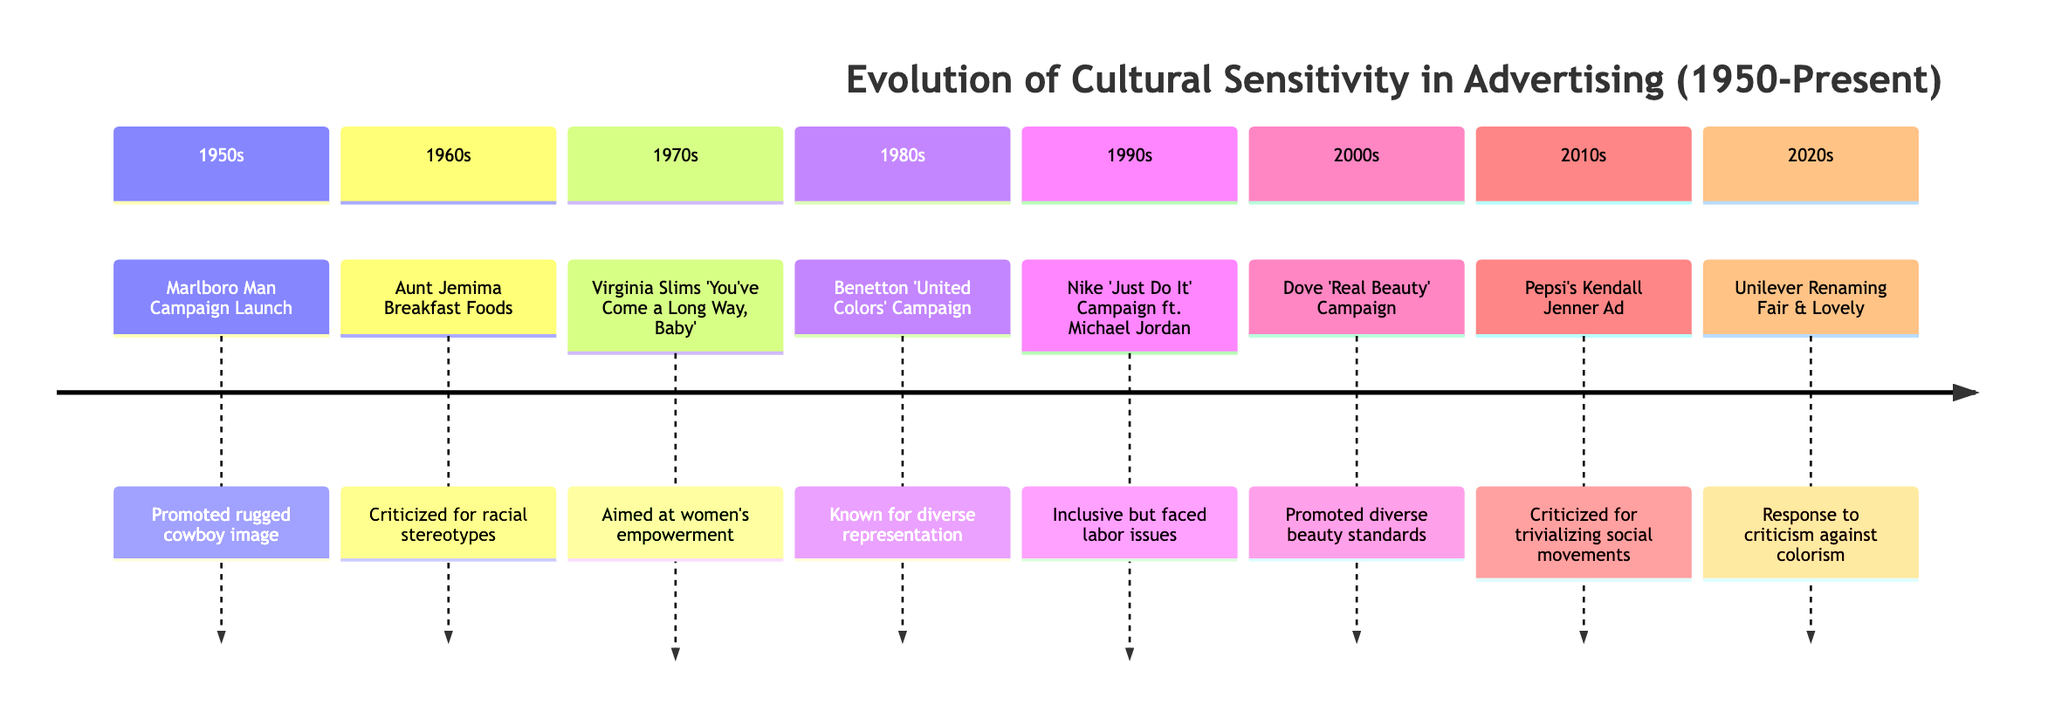What event was launched in the 1950s? The timeline indicates the "Marlboro Man Campaign Launch" as the event launched in the 1950s.
Answer: Marlboro Man Campaign Launch Which campaign aimed at women's empowerment in the 1970s? According to the timeline, the "Virginia Slims 'You've Come a Long Way, Baby'" campaign is mentioned as aiming at women's empowerment in the 1970s.
Answer: Virginia Slims 'You've Come a Long Way, Baby' How many decades are represented in the timeline? The timeline spans from the 1950s to the 2020s, which amounts to a total of 7 decades represented.
Answer: 7 What was a significant focus of the 1980s Benetton campaign? The timeline describes the Benetton "United Colors" Campaign as known for its "diverse representation," indicating that diversity was a significant focus.
Answer: diverse representation Which campaign faced backlash over labor practices during the 1990s? The timeline points out that the Nike "Just Do It" Campaign ft. Michael Jordan faced backlash over labor practices in other cultures during the 1990s.
Answer: Nike 'Just Do It' Campaign ft. Michael Jordan What major issue was highlighted by Pepsi's 2010s ad? The timeline describes Pepsi's "Kendall Jenner Ad" as being criticized for trivializing social justice movements, indicating this was the major issue highlighted.
Answer: trivializing social justice movements In which decade did Unilever rename Fair & Lovely? According to the timeline, Unilever renamed Fair & Lovely to Glow & Lovely in the 2020s.
Answer: 2020s What was a key criticism of Dove's campaign in the 2000s? The timeline mentions that Dove's "Real Beauty" Campaign was criticized for being perceived as "non-genuine corporate social responsibility," indicating this key criticism.
Answer: non-genuine corporate social responsibility 